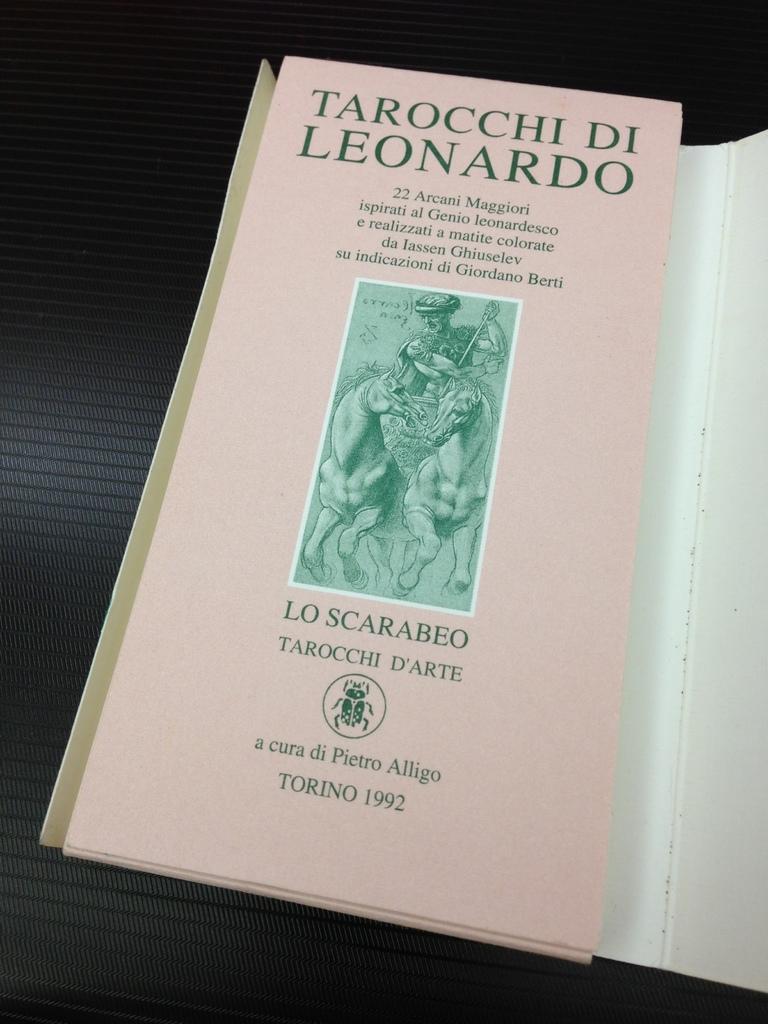What year was the book written ?
Provide a short and direct response. 1992. Who wrote the book?
Make the answer very short. Tarocchi di leonardo. 